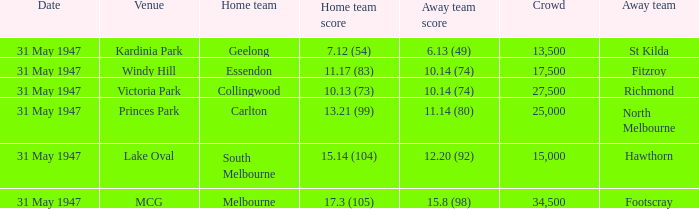What day is south melbourne at home? 31 May 1947. 